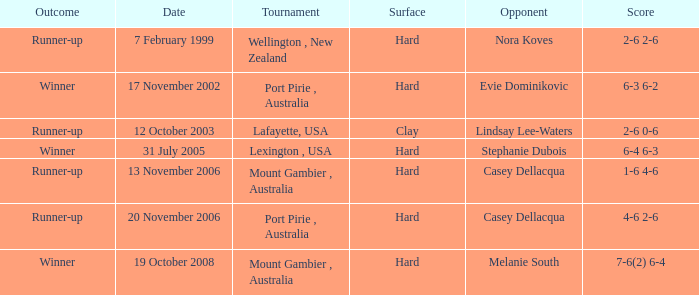Which Outcome has a Opponent of lindsay lee-waters? Runner-up. 